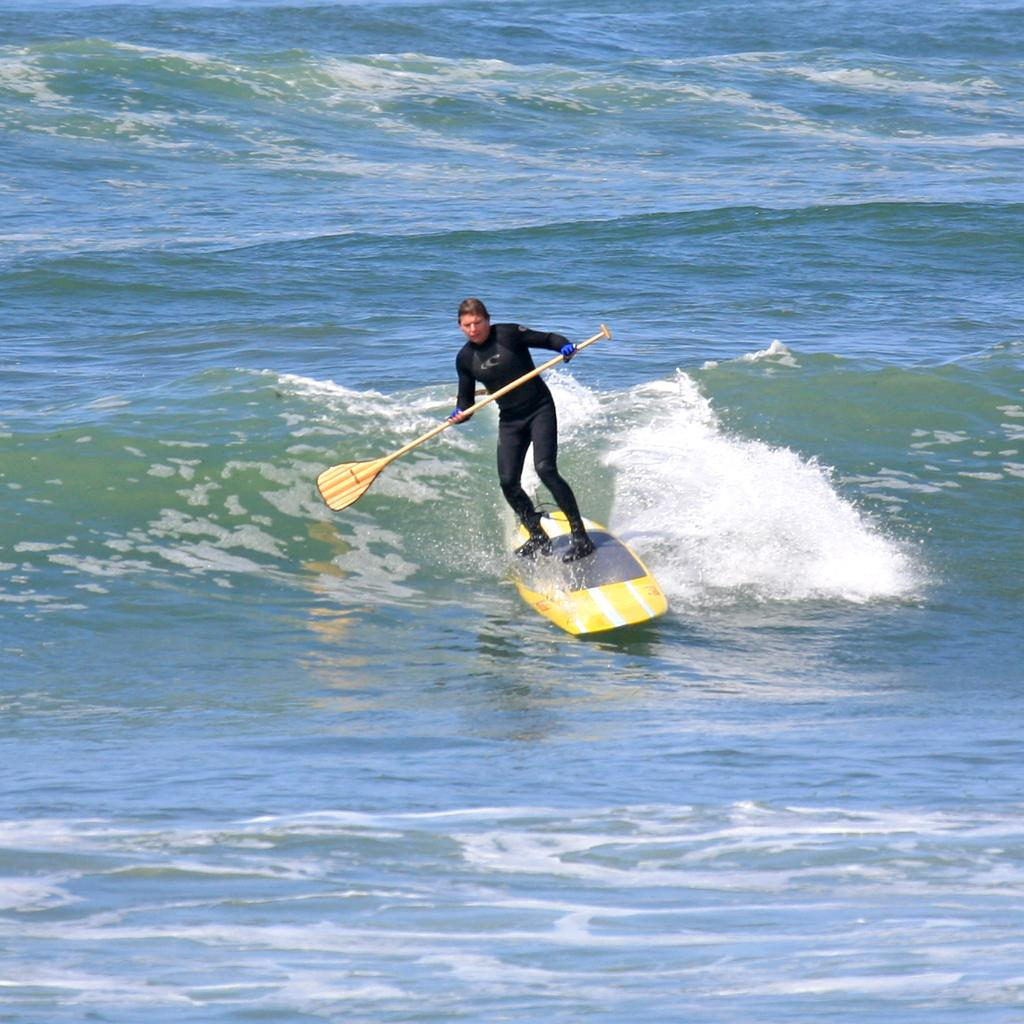What is the main subject of the image? There is a person in the image. What is the person wearing? The person is wearing a black dress. What is the person holding in the image? The person is holding a paddle. What is the person standing on in the image? The person is standing on a surfboard. What is the surfboard doing in the image? The surfboard is surfing on the water. What can be seen in the background of the image? There is a wave visible in the image. How many houses can be seen in the image? There are no houses visible in the image; it features a person surfing on a wave. Is the person wearing a mask in the image? There is no mask visible on the person in the image. 